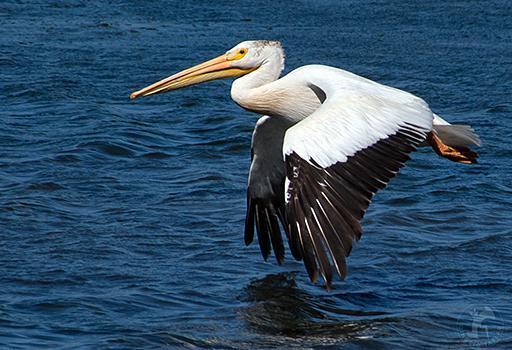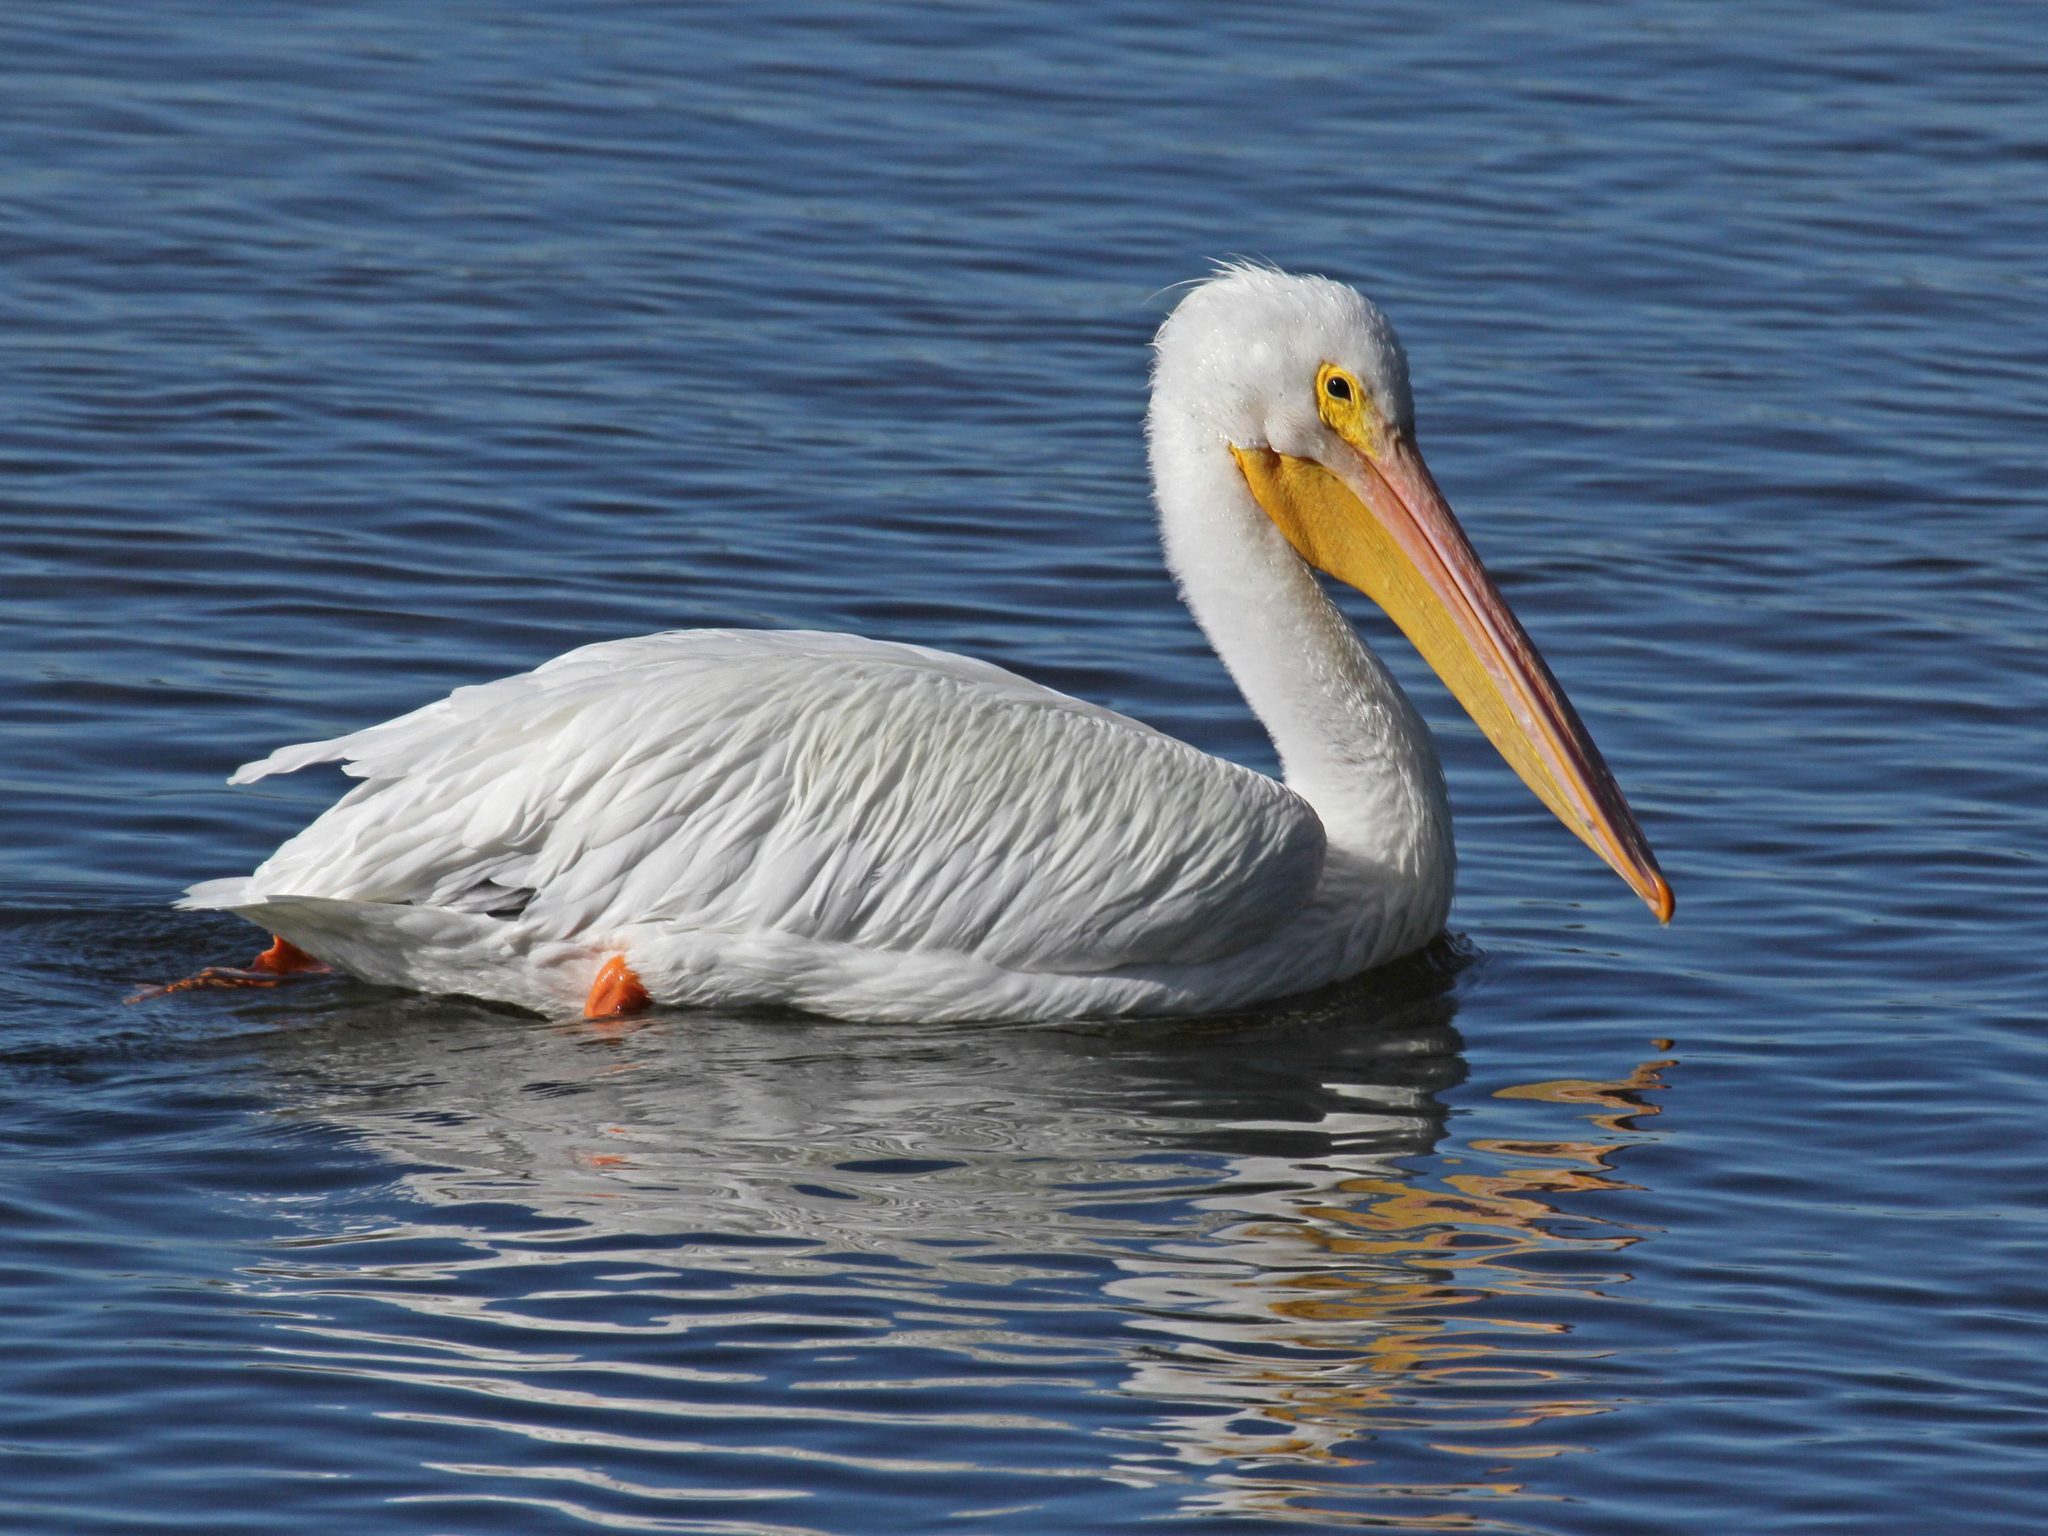The first image is the image on the left, the second image is the image on the right. Evaluate the accuracy of this statement regarding the images: "One image shows exactly one pelican on water facing right, and the other image shows a pelican flying above water.". Is it true? Answer yes or no. Yes. The first image is the image on the left, the second image is the image on the right. Given the left and right images, does the statement "there is a single pelican in flight with the wings in the downward position" hold true? Answer yes or no. Yes. 